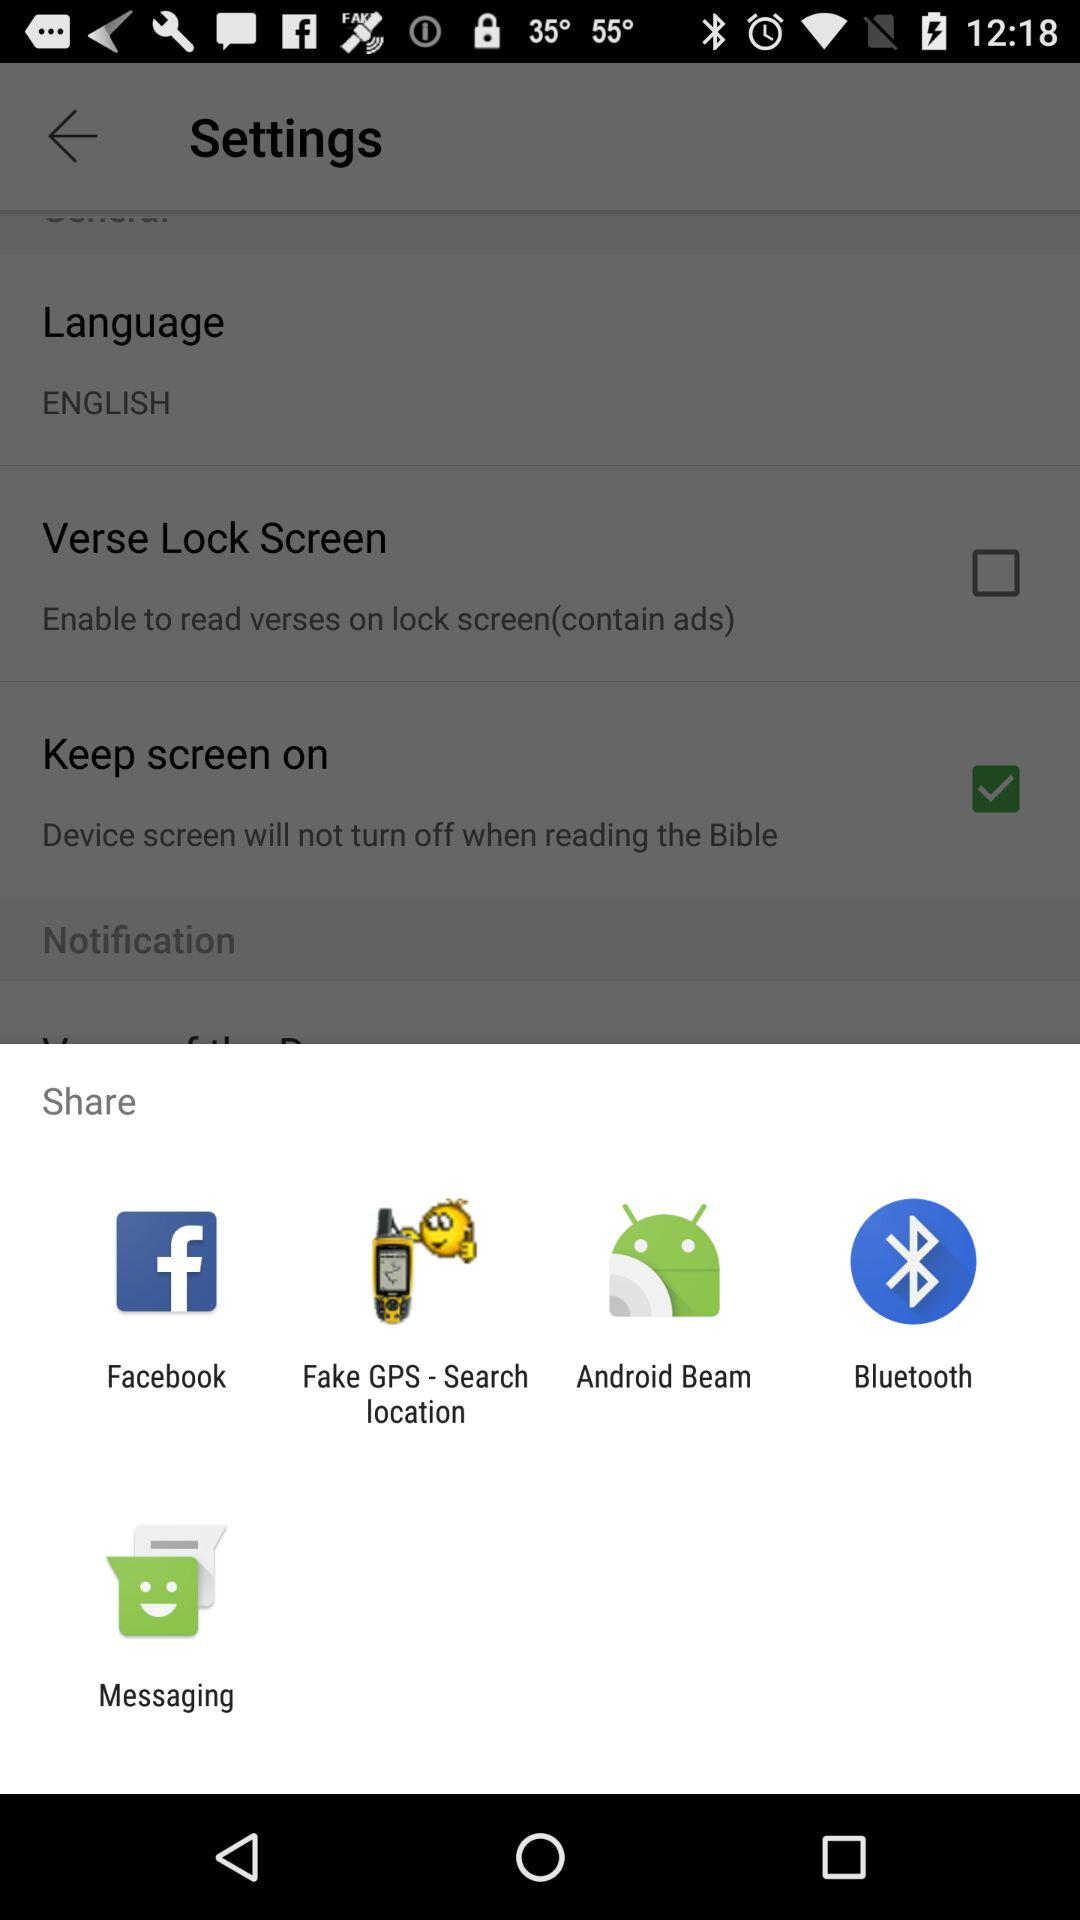How many of the items have a checkbox?
Answer the question using a single word or phrase. 2 